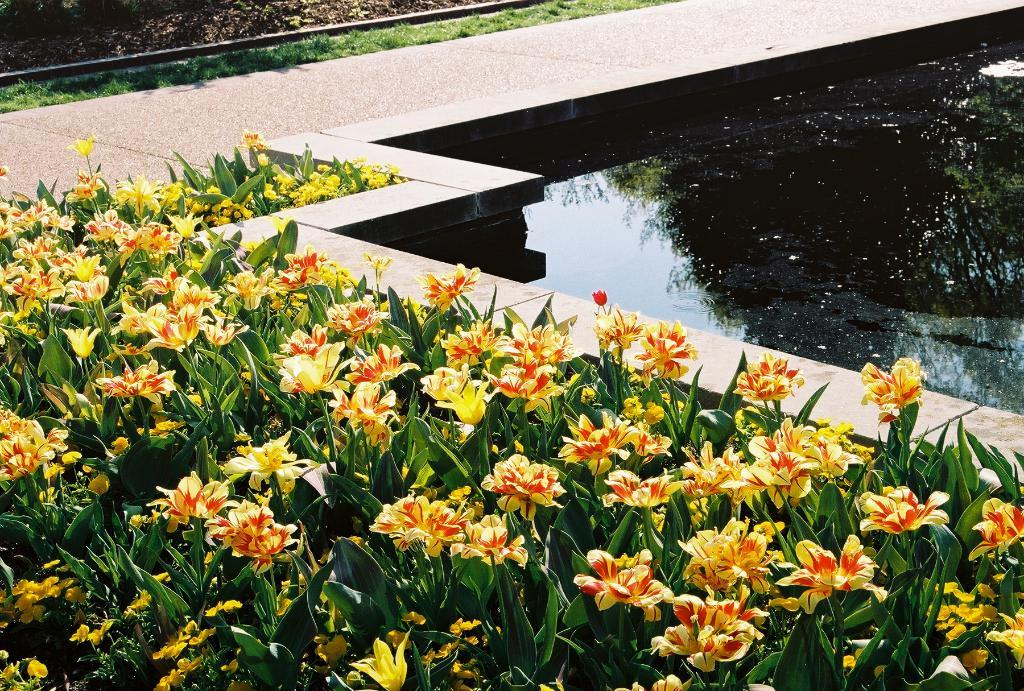What is the primary element visible in the image? There is water in the image. What type of vegetation can be seen in the image? There are plants with flowers in the image. What type of ground cover is present in the image? There is grass on the ground in the image. What color is the scarf draped over the tree in the image? There is no scarf present in the image. How many cars can be seen driving through the water in the image? There are no cars visible in the image; it only features water, plants with flowers, and grass. 